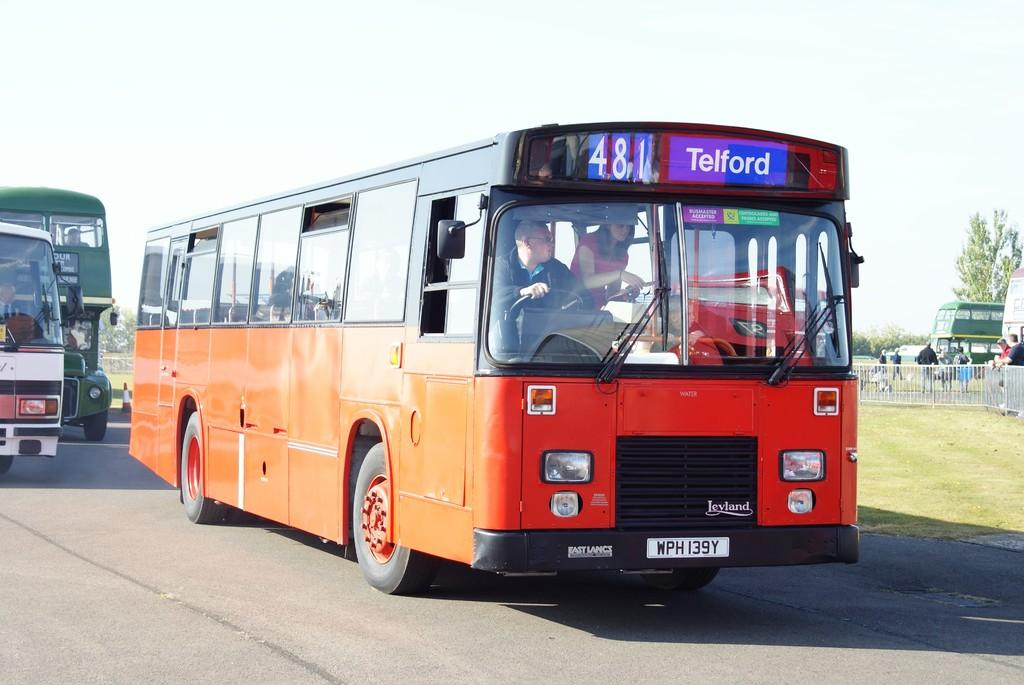<image>
Create a compact narrative representing the image presented. Orange bus on the road that is headed towards Telford. 